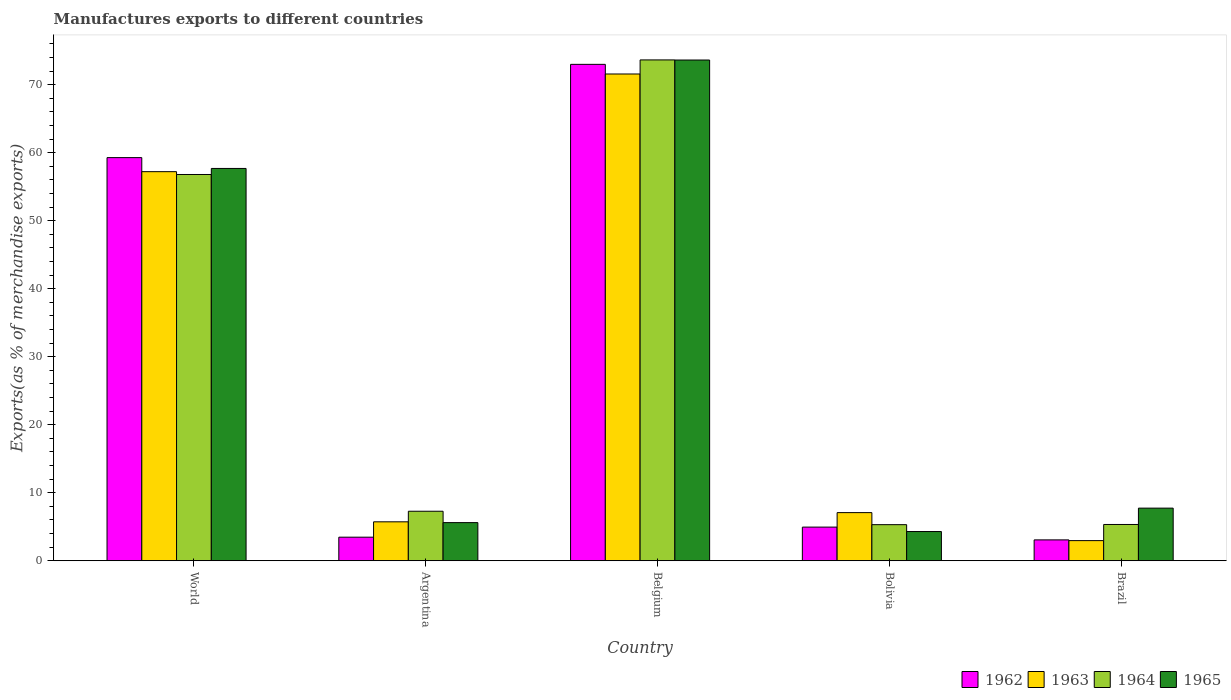How many different coloured bars are there?
Ensure brevity in your answer.  4. How many groups of bars are there?
Your response must be concise. 5. Are the number of bars per tick equal to the number of legend labels?
Your answer should be very brief. Yes. How many bars are there on the 4th tick from the left?
Your response must be concise. 4. What is the label of the 4th group of bars from the left?
Ensure brevity in your answer.  Bolivia. In how many cases, is the number of bars for a given country not equal to the number of legend labels?
Ensure brevity in your answer.  0. What is the percentage of exports to different countries in 1962 in Brazil?
Give a very brief answer. 3.07. Across all countries, what is the maximum percentage of exports to different countries in 1963?
Offer a terse response. 71.56. Across all countries, what is the minimum percentage of exports to different countries in 1964?
Your response must be concise. 5.31. In which country was the percentage of exports to different countries in 1964 minimum?
Keep it short and to the point. Bolivia. What is the total percentage of exports to different countries in 1965 in the graph?
Offer a terse response. 148.94. What is the difference between the percentage of exports to different countries in 1964 in Belgium and that in Brazil?
Make the answer very short. 68.3. What is the difference between the percentage of exports to different countries in 1963 in Bolivia and the percentage of exports to different countries in 1962 in World?
Your response must be concise. -52.19. What is the average percentage of exports to different countries in 1962 per country?
Ensure brevity in your answer.  28.75. What is the difference between the percentage of exports to different countries of/in 1962 and percentage of exports to different countries of/in 1963 in Bolivia?
Provide a short and direct response. -2.13. In how many countries, is the percentage of exports to different countries in 1965 greater than 34 %?
Your answer should be compact. 2. What is the ratio of the percentage of exports to different countries in 1965 in Belgium to that in World?
Keep it short and to the point. 1.28. Is the percentage of exports to different countries in 1962 in Belgium less than that in Brazil?
Your answer should be very brief. No. Is the difference between the percentage of exports to different countries in 1962 in Argentina and World greater than the difference between the percentage of exports to different countries in 1963 in Argentina and World?
Provide a succinct answer. No. What is the difference between the highest and the second highest percentage of exports to different countries in 1963?
Your answer should be compact. 50.12. What is the difference between the highest and the lowest percentage of exports to different countries in 1963?
Keep it short and to the point. 68.6. Is the sum of the percentage of exports to different countries in 1964 in Belgium and Brazil greater than the maximum percentage of exports to different countries in 1963 across all countries?
Your response must be concise. Yes. Is it the case that in every country, the sum of the percentage of exports to different countries in 1964 and percentage of exports to different countries in 1963 is greater than the sum of percentage of exports to different countries in 1962 and percentage of exports to different countries in 1965?
Give a very brief answer. No. What does the 1st bar from the left in Belgium represents?
Your response must be concise. 1962. What does the 3rd bar from the right in Argentina represents?
Your answer should be compact. 1963. Is it the case that in every country, the sum of the percentage of exports to different countries in 1962 and percentage of exports to different countries in 1965 is greater than the percentage of exports to different countries in 1964?
Your answer should be very brief. Yes. Are all the bars in the graph horizontal?
Provide a short and direct response. No. Does the graph contain any zero values?
Your answer should be very brief. No. What is the title of the graph?
Keep it short and to the point. Manufactures exports to different countries. Does "1996" appear as one of the legend labels in the graph?
Offer a terse response. No. What is the label or title of the Y-axis?
Offer a very short reply. Exports(as % of merchandise exports). What is the Exports(as % of merchandise exports) of 1962 in World?
Offer a terse response. 59.27. What is the Exports(as % of merchandise exports) in 1963 in World?
Your answer should be very brief. 57.2. What is the Exports(as % of merchandise exports) in 1964 in World?
Ensure brevity in your answer.  56.79. What is the Exports(as % of merchandise exports) of 1965 in World?
Provide a short and direct response. 57.68. What is the Exports(as % of merchandise exports) in 1962 in Argentina?
Offer a very short reply. 3.47. What is the Exports(as % of merchandise exports) of 1963 in Argentina?
Make the answer very short. 5.73. What is the Exports(as % of merchandise exports) of 1964 in Argentina?
Provide a short and direct response. 7.28. What is the Exports(as % of merchandise exports) of 1965 in Argentina?
Offer a very short reply. 5.61. What is the Exports(as % of merchandise exports) in 1962 in Belgium?
Ensure brevity in your answer.  72.98. What is the Exports(as % of merchandise exports) in 1963 in Belgium?
Provide a short and direct response. 71.56. What is the Exports(as % of merchandise exports) in 1964 in Belgium?
Give a very brief answer. 73.63. What is the Exports(as % of merchandise exports) in 1965 in Belgium?
Give a very brief answer. 73.62. What is the Exports(as % of merchandise exports) of 1962 in Bolivia?
Keep it short and to the point. 4.95. What is the Exports(as % of merchandise exports) of 1963 in Bolivia?
Ensure brevity in your answer.  7.08. What is the Exports(as % of merchandise exports) of 1964 in Bolivia?
Give a very brief answer. 5.31. What is the Exports(as % of merchandise exports) in 1965 in Bolivia?
Your answer should be very brief. 4.3. What is the Exports(as % of merchandise exports) in 1962 in Brazil?
Provide a succinct answer. 3.07. What is the Exports(as % of merchandise exports) in 1963 in Brazil?
Offer a terse response. 2.96. What is the Exports(as % of merchandise exports) in 1964 in Brazil?
Your answer should be compact. 5.34. What is the Exports(as % of merchandise exports) in 1965 in Brazil?
Your answer should be compact. 7.74. Across all countries, what is the maximum Exports(as % of merchandise exports) in 1962?
Keep it short and to the point. 72.98. Across all countries, what is the maximum Exports(as % of merchandise exports) in 1963?
Your response must be concise. 71.56. Across all countries, what is the maximum Exports(as % of merchandise exports) of 1964?
Your response must be concise. 73.63. Across all countries, what is the maximum Exports(as % of merchandise exports) of 1965?
Your response must be concise. 73.62. Across all countries, what is the minimum Exports(as % of merchandise exports) of 1962?
Your response must be concise. 3.07. Across all countries, what is the minimum Exports(as % of merchandise exports) in 1963?
Provide a short and direct response. 2.96. Across all countries, what is the minimum Exports(as % of merchandise exports) in 1964?
Give a very brief answer. 5.31. Across all countries, what is the minimum Exports(as % of merchandise exports) of 1965?
Offer a very short reply. 4.3. What is the total Exports(as % of merchandise exports) in 1962 in the graph?
Offer a terse response. 143.74. What is the total Exports(as % of merchandise exports) of 1963 in the graph?
Provide a succinct answer. 144.54. What is the total Exports(as % of merchandise exports) in 1964 in the graph?
Ensure brevity in your answer.  148.35. What is the total Exports(as % of merchandise exports) in 1965 in the graph?
Ensure brevity in your answer.  148.94. What is the difference between the Exports(as % of merchandise exports) in 1962 in World and that in Argentina?
Ensure brevity in your answer.  55.8. What is the difference between the Exports(as % of merchandise exports) of 1963 in World and that in Argentina?
Keep it short and to the point. 51.48. What is the difference between the Exports(as % of merchandise exports) of 1964 in World and that in Argentina?
Ensure brevity in your answer.  49.51. What is the difference between the Exports(as % of merchandise exports) of 1965 in World and that in Argentina?
Your answer should be compact. 52.07. What is the difference between the Exports(as % of merchandise exports) in 1962 in World and that in Belgium?
Your answer should be very brief. -13.71. What is the difference between the Exports(as % of merchandise exports) of 1963 in World and that in Belgium?
Ensure brevity in your answer.  -14.36. What is the difference between the Exports(as % of merchandise exports) of 1964 in World and that in Belgium?
Make the answer very short. -16.84. What is the difference between the Exports(as % of merchandise exports) in 1965 in World and that in Belgium?
Provide a short and direct response. -15.94. What is the difference between the Exports(as % of merchandise exports) of 1962 in World and that in Bolivia?
Offer a terse response. 54.32. What is the difference between the Exports(as % of merchandise exports) of 1963 in World and that in Bolivia?
Your answer should be compact. 50.12. What is the difference between the Exports(as % of merchandise exports) in 1964 in World and that in Bolivia?
Give a very brief answer. 51.48. What is the difference between the Exports(as % of merchandise exports) in 1965 in World and that in Bolivia?
Offer a terse response. 53.38. What is the difference between the Exports(as % of merchandise exports) in 1962 in World and that in Brazil?
Provide a succinct answer. 56.2. What is the difference between the Exports(as % of merchandise exports) in 1963 in World and that in Brazil?
Give a very brief answer. 54.24. What is the difference between the Exports(as % of merchandise exports) of 1964 in World and that in Brazil?
Your response must be concise. 51.45. What is the difference between the Exports(as % of merchandise exports) of 1965 in World and that in Brazil?
Your response must be concise. 49.94. What is the difference between the Exports(as % of merchandise exports) of 1962 in Argentina and that in Belgium?
Keep it short and to the point. -69.51. What is the difference between the Exports(as % of merchandise exports) in 1963 in Argentina and that in Belgium?
Your answer should be very brief. -65.84. What is the difference between the Exports(as % of merchandise exports) of 1964 in Argentina and that in Belgium?
Your answer should be very brief. -66.35. What is the difference between the Exports(as % of merchandise exports) of 1965 in Argentina and that in Belgium?
Your answer should be very brief. -68.01. What is the difference between the Exports(as % of merchandise exports) in 1962 in Argentina and that in Bolivia?
Keep it short and to the point. -1.48. What is the difference between the Exports(as % of merchandise exports) in 1963 in Argentina and that in Bolivia?
Provide a succinct answer. -1.35. What is the difference between the Exports(as % of merchandise exports) in 1964 in Argentina and that in Bolivia?
Provide a short and direct response. 1.97. What is the difference between the Exports(as % of merchandise exports) in 1965 in Argentina and that in Bolivia?
Make the answer very short. 1.31. What is the difference between the Exports(as % of merchandise exports) in 1962 in Argentina and that in Brazil?
Your response must be concise. 0.4. What is the difference between the Exports(as % of merchandise exports) of 1963 in Argentina and that in Brazil?
Your answer should be very brief. 2.76. What is the difference between the Exports(as % of merchandise exports) in 1964 in Argentina and that in Brazil?
Offer a terse response. 1.95. What is the difference between the Exports(as % of merchandise exports) in 1965 in Argentina and that in Brazil?
Your response must be concise. -2.13. What is the difference between the Exports(as % of merchandise exports) in 1962 in Belgium and that in Bolivia?
Give a very brief answer. 68.03. What is the difference between the Exports(as % of merchandise exports) in 1963 in Belgium and that in Bolivia?
Offer a terse response. 64.48. What is the difference between the Exports(as % of merchandise exports) in 1964 in Belgium and that in Bolivia?
Provide a succinct answer. 68.32. What is the difference between the Exports(as % of merchandise exports) in 1965 in Belgium and that in Bolivia?
Ensure brevity in your answer.  69.32. What is the difference between the Exports(as % of merchandise exports) of 1962 in Belgium and that in Brazil?
Give a very brief answer. 69.91. What is the difference between the Exports(as % of merchandise exports) in 1963 in Belgium and that in Brazil?
Your response must be concise. 68.6. What is the difference between the Exports(as % of merchandise exports) in 1964 in Belgium and that in Brazil?
Your answer should be very brief. 68.3. What is the difference between the Exports(as % of merchandise exports) of 1965 in Belgium and that in Brazil?
Provide a short and direct response. 65.88. What is the difference between the Exports(as % of merchandise exports) in 1962 in Bolivia and that in Brazil?
Your answer should be compact. 1.88. What is the difference between the Exports(as % of merchandise exports) of 1963 in Bolivia and that in Brazil?
Provide a short and direct response. 4.12. What is the difference between the Exports(as % of merchandise exports) in 1964 in Bolivia and that in Brazil?
Give a very brief answer. -0.03. What is the difference between the Exports(as % of merchandise exports) in 1965 in Bolivia and that in Brazil?
Provide a short and direct response. -3.44. What is the difference between the Exports(as % of merchandise exports) of 1962 in World and the Exports(as % of merchandise exports) of 1963 in Argentina?
Provide a short and direct response. 53.55. What is the difference between the Exports(as % of merchandise exports) in 1962 in World and the Exports(as % of merchandise exports) in 1964 in Argentina?
Keep it short and to the point. 51.99. What is the difference between the Exports(as % of merchandise exports) of 1962 in World and the Exports(as % of merchandise exports) of 1965 in Argentina?
Your response must be concise. 53.66. What is the difference between the Exports(as % of merchandise exports) of 1963 in World and the Exports(as % of merchandise exports) of 1964 in Argentina?
Keep it short and to the point. 49.92. What is the difference between the Exports(as % of merchandise exports) in 1963 in World and the Exports(as % of merchandise exports) in 1965 in Argentina?
Your response must be concise. 51.59. What is the difference between the Exports(as % of merchandise exports) in 1964 in World and the Exports(as % of merchandise exports) in 1965 in Argentina?
Give a very brief answer. 51.18. What is the difference between the Exports(as % of merchandise exports) in 1962 in World and the Exports(as % of merchandise exports) in 1963 in Belgium?
Provide a short and direct response. -12.29. What is the difference between the Exports(as % of merchandise exports) of 1962 in World and the Exports(as % of merchandise exports) of 1964 in Belgium?
Offer a terse response. -14.36. What is the difference between the Exports(as % of merchandise exports) of 1962 in World and the Exports(as % of merchandise exports) of 1965 in Belgium?
Offer a terse response. -14.35. What is the difference between the Exports(as % of merchandise exports) of 1963 in World and the Exports(as % of merchandise exports) of 1964 in Belgium?
Offer a very short reply. -16.43. What is the difference between the Exports(as % of merchandise exports) of 1963 in World and the Exports(as % of merchandise exports) of 1965 in Belgium?
Offer a very short reply. -16.41. What is the difference between the Exports(as % of merchandise exports) of 1964 in World and the Exports(as % of merchandise exports) of 1965 in Belgium?
Offer a terse response. -16.83. What is the difference between the Exports(as % of merchandise exports) in 1962 in World and the Exports(as % of merchandise exports) in 1963 in Bolivia?
Ensure brevity in your answer.  52.19. What is the difference between the Exports(as % of merchandise exports) in 1962 in World and the Exports(as % of merchandise exports) in 1964 in Bolivia?
Provide a short and direct response. 53.96. What is the difference between the Exports(as % of merchandise exports) in 1962 in World and the Exports(as % of merchandise exports) in 1965 in Bolivia?
Your answer should be compact. 54.97. What is the difference between the Exports(as % of merchandise exports) in 1963 in World and the Exports(as % of merchandise exports) in 1964 in Bolivia?
Your response must be concise. 51.89. What is the difference between the Exports(as % of merchandise exports) of 1963 in World and the Exports(as % of merchandise exports) of 1965 in Bolivia?
Your answer should be very brief. 52.91. What is the difference between the Exports(as % of merchandise exports) of 1964 in World and the Exports(as % of merchandise exports) of 1965 in Bolivia?
Your response must be concise. 52.49. What is the difference between the Exports(as % of merchandise exports) in 1962 in World and the Exports(as % of merchandise exports) in 1963 in Brazil?
Offer a very short reply. 56.31. What is the difference between the Exports(as % of merchandise exports) of 1962 in World and the Exports(as % of merchandise exports) of 1964 in Brazil?
Offer a very short reply. 53.93. What is the difference between the Exports(as % of merchandise exports) in 1962 in World and the Exports(as % of merchandise exports) in 1965 in Brazil?
Give a very brief answer. 51.53. What is the difference between the Exports(as % of merchandise exports) of 1963 in World and the Exports(as % of merchandise exports) of 1964 in Brazil?
Provide a short and direct response. 51.87. What is the difference between the Exports(as % of merchandise exports) in 1963 in World and the Exports(as % of merchandise exports) in 1965 in Brazil?
Provide a succinct answer. 49.46. What is the difference between the Exports(as % of merchandise exports) in 1964 in World and the Exports(as % of merchandise exports) in 1965 in Brazil?
Your response must be concise. 49.05. What is the difference between the Exports(as % of merchandise exports) of 1962 in Argentina and the Exports(as % of merchandise exports) of 1963 in Belgium?
Ensure brevity in your answer.  -68.1. What is the difference between the Exports(as % of merchandise exports) of 1962 in Argentina and the Exports(as % of merchandise exports) of 1964 in Belgium?
Provide a succinct answer. -70.16. What is the difference between the Exports(as % of merchandise exports) in 1962 in Argentina and the Exports(as % of merchandise exports) in 1965 in Belgium?
Offer a very short reply. -70.15. What is the difference between the Exports(as % of merchandise exports) of 1963 in Argentina and the Exports(as % of merchandise exports) of 1964 in Belgium?
Give a very brief answer. -67.91. What is the difference between the Exports(as % of merchandise exports) in 1963 in Argentina and the Exports(as % of merchandise exports) in 1965 in Belgium?
Offer a terse response. -67.89. What is the difference between the Exports(as % of merchandise exports) of 1964 in Argentina and the Exports(as % of merchandise exports) of 1965 in Belgium?
Provide a succinct answer. -66.33. What is the difference between the Exports(as % of merchandise exports) in 1962 in Argentina and the Exports(as % of merchandise exports) in 1963 in Bolivia?
Provide a short and direct response. -3.61. What is the difference between the Exports(as % of merchandise exports) in 1962 in Argentina and the Exports(as % of merchandise exports) in 1964 in Bolivia?
Your response must be concise. -1.84. What is the difference between the Exports(as % of merchandise exports) of 1962 in Argentina and the Exports(as % of merchandise exports) of 1965 in Bolivia?
Provide a short and direct response. -0.83. What is the difference between the Exports(as % of merchandise exports) in 1963 in Argentina and the Exports(as % of merchandise exports) in 1964 in Bolivia?
Ensure brevity in your answer.  0.42. What is the difference between the Exports(as % of merchandise exports) in 1963 in Argentina and the Exports(as % of merchandise exports) in 1965 in Bolivia?
Your answer should be very brief. 1.43. What is the difference between the Exports(as % of merchandise exports) in 1964 in Argentina and the Exports(as % of merchandise exports) in 1965 in Bolivia?
Provide a short and direct response. 2.98. What is the difference between the Exports(as % of merchandise exports) of 1962 in Argentina and the Exports(as % of merchandise exports) of 1963 in Brazil?
Keep it short and to the point. 0.51. What is the difference between the Exports(as % of merchandise exports) in 1962 in Argentina and the Exports(as % of merchandise exports) in 1964 in Brazil?
Provide a short and direct response. -1.87. What is the difference between the Exports(as % of merchandise exports) in 1962 in Argentina and the Exports(as % of merchandise exports) in 1965 in Brazil?
Offer a very short reply. -4.27. What is the difference between the Exports(as % of merchandise exports) of 1963 in Argentina and the Exports(as % of merchandise exports) of 1964 in Brazil?
Offer a terse response. 0.39. What is the difference between the Exports(as % of merchandise exports) in 1963 in Argentina and the Exports(as % of merchandise exports) in 1965 in Brazil?
Offer a very short reply. -2.01. What is the difference between the Exports(as % of merchandise exports) of 1964 in Argentina and the Exports(as % of merchandise exports) of 1965 in Brazil?
Offer a terse response. -0.46. What is the difference between the Exports(as % of merchandise exports) of 1962 in Belgium and the Exports(as % of merchandise exports) of 1963 in Bolivia?
Provide a succinct answer. 65.9. What is the difference between the Exports(as % of merchandise exports) in 1962 in Belgium and the Exports(as % of merchandise exports) in 1964 in Bolivia?
Ensure brevity in your answer.  67.67. What is the difference between the Exports(as % of merchandise exports) in 1962 in Belgium and the Exports(as % of merchandise exports) in 1965 in Bolivia?
Give a very brief answer. 68.68. What is the difference between the Exports(as % of merchandise exports) of 1963 in Belgium and the Exports(as % of merchandise exports) of 1964 in Bolivia?
Give a very brief answer. 66.25. What is the difference between the Exports(as % of merchandise exports) in 1963 in Belgium and the Exports(as % of merchandise exports) in 1965 in Bolivia?
Give a very brief answer. 67.27. What is the difference between the Exports(as % of merchandise exports) of 1964 in Belgium and the Exports(as % of merchandise exports) of 1965 in Bolivia?
Offer a terse response. 69.34. What is the difference between the Exports(as % of merchandise exports) of 1962 in Belgium and the Exports(as % of merchandise exports) of 1963 in Brazil?
Offer a terse response. 70.02. What is the difference between the Exports(as % of merchandise exports) of 1962 in Belgium and the Exports(as % of merchandise exports) of 1964 in Brazil?
Ensure brevity in your answer.  67.64. What is the difference between the Exports(as % of merchandise exports) of 1962 in Belgium and the Exports(as % of merchandise exports) of 1965 in Brazil?
Your answer should be compact. 65.24. What is the difference between the Exports(as % of merchandise exports) of 1963 in Belgium and the Exports(as % of merchandise exports) of 1964 in Brazil?
Provide a short and direct response. 66.23. What is the difference between the Exports(as % of merchandise exports) of 1963 in Belgium and the Exports(as % of merchandise exports) of 1965 in Brazil?
Your answer should be very brief. 63.82. What is the difference between the Exports(as % of merchandise exports) in 1964 in Belgium and the Exports(as % of merchandise exports) in 1965 in Brazil?
Ensure brevity in your answer.  65.89. What is the difference between the Exports(as % of merchandise exports) of 1962 in Bolivia and the Exports(as % of merchandise exports) of 1963 in Brazil?
Give a very brief answer. 1.99. What is the difference between the Exports(as % of merchandise exports) of 1962 in Bolivia and the Exports(as % of merchandise exports) of 1964 in Brazil?
Keep it short and to the point. -0.39. What is the difference between the Exports(as % of merchandise exports) of 1962 in Bolivia and the Exports(as % of merchandise exports) of 1965 in Brazil?
Ensure brevity in your answer.  -2.79. What is the difference between the Exports(as % of merchandise exports) of 1963 in Bolivia and the Exports(as % of merchandise exports) of 1964 in Brazil?
Make the answer very short. 1.74. What is the difference between the Exports(as % of merchandise exports) of 1963 in Bolivia and the Exports(as % of merchandise exports) of 1965 in Brazil?
Your answer should be very brief. -0.66. What is the difference between the Exports(as % of merchandise exports) in 1964 in Bolivia and the Exports(as % of merchandise exports) in 1965 in Brazil?
Offer a terse response. -2.43. What is the average Exports(as % of merchandise exports) of 1962 per country?
Give a very brief answer. 28.75. What is the average Exports(as % of merchandise exports) of 1963 per country?
Keep it short and to the point. 28.91. What is the average Exports(as % of merchandise exports) in 1964 per country?
Provide a short and direct response. 29.67. What is the average Exports(as % of merchandise exports) in 1965 per country?
Offer a terse response. 29.79. What is the difference between the Exports(as % of merchandise exports) of 1962 and Exports(as % of merchandise exports) of 1963 in World?
Make the answer very short. 2.07. What is the difference between the Exports(as % of merchandise exports) of 1962 and Exports(as % of merchandise exports) of 1964 in World?
Your response must be concise. 2.48. What is the difference between the Exports(as % of merchandise exports) of 1962 and Exports(as % of merchandise exports) of 1965 in World?
Provide a short and direct response. 1.59. What is the difference between the Exports(as % of merchandise exports) in 1963 and Exports(as % of merchandise exports) in 1964 in World?
Offer a terse response. 0.41. What is the difference between the Exports(as % of merchandise exports) in 1963 and Exports(as % of merchandise exports) in 1965 in World?
Provide a succinct answer. -0.47. What is the difference between the Exports(as % of merchandise exports) in 1964 and Exports(as % of merchandise exports) in 1965 in World?
Provide a succinct answer. -0.89. What is the difference between the Exports(as % of merchandise exports) of 1962 and Exports(as % of merchandise exports) of 1963 in Argentina?
Your answer should be very brief. -2.26. What is the difference between the Exports(as % of merchandise exports) of 1962 and Exports(as % of merchandise exports) of 1964 in Argentina?
Give a very brief answer. -3.81. What is the difference between the Exports(as % of merchandise exports) of 1962 and Exports(as % of merchandise exports) of 1965 in Argentina?
Ensure brevity in your answer.  -2.14. What is the difference between the Exports(as % of merchandise exports) in 1963 and Exports(as % of merchandise exports) in 1964 in Argentina?
Your answer should be compact. -1.56. What is the difference between the Exports(as % of merchandise exports) in 1963 and Exports(as % of merchandise exports) in 1965 in Argentina?
Make the answer very short. 0.12. What is the difference between the Exports(as % of merchandise exports) of 1964 and Exports(as % of merchandise exports) of 1965 in Argentina?
Offer a terse response. 1.67. What is the difference between the Exports(as % of merchandise exports) of 1962 and Exports(as % of merchandise exports) of 1963 in Belgium?
Your response must be concise. 1.42. What is the difference between the Exports(as % of merchandise exports) in 1962 and Exports(as % of merchandise exports) in 1964 in Belgium?
Your response must be concise. -0.65. What is the difference between the Exports(as % of merchandise exports) of 1962 and Exports(as % of merchandise exports) of 1965 in Belgium?
Provide a short and direct response. -0.64. What is the difference between the Exports(as % of merchandise exports) in 1963 and Exports(as % of merchandise exports) in 1964 in Belgium?
Offer a terse response. -2.07. What is the difference between the Exports(as % of merchandise exports) of 1963 and Exports(as % of merchandise exports) of 1965 in Belgium?
Your answer should be very brief. -2.05. What is the difference between the Exports(as % of merchandise exports) in 1964 and Exports(as % of merchandise exports) in 1965 in Belgium?
Provide a succinct answer. 0.02. What is the difference between the Exports(as % of merchandise exports) in 1962 and Exports(as % of merchandise exports) in 1963 in Bolivia?
Your answer should be very brief. -2.13. What is the difference between the Exports(as % of merchandise exports) in 1962 and Exports(as % of merchandise exports) in 1964 in Bolivia?
Give a very brief answer. -0.36. What is the difference between the Exports(as % of merchandise exports) in 1962 and Exports(as % of merchandise exports) in 1965 in Bolivia?
Keep it short and to the point. 0.65. What is the difference between the Exports(as % of merchandise exports) in 1963 and Exports(as % of merchandise exports) in 1964 in Bolivia?
Provide a succinct answer. 1.77. What is the difference between the Exports(as % of merchandise exports) of 1963 and Exports(as % of merchandise exports) of 1965 in Bolivia?
Keep it short and to the point. 2.78. What is the difference between the Exports(as % of merchandise exports) of 1964 and Exports(as % of merchandise exports) of 1965 in Bolivia?
Your answer should be compact. 1.01. What is the difference between the Exports(as % of merchandise exports) of 1962 and Exports(as % of merchandise exports) of 1963 in Brazil?
Keep it short and to the point. 0.11. What is the difference between the Exports(as % of merchandise exports) of 1962 and Exports(as % of merchandise exports) of 1964 in Brazil?
Keep it short and to the point. -2.27. What is the difference between the Exports(as % of merchandise exports) of 1962 and Exports(as % of merchandise exports) of 1965 in Brazil?
Offer a terse response. -4.67. What is the difference between the Exports(as % of merchandise exports) in 1963 and Exports(as % of merchandise exports) in 1964 in Brazil?
Make the answer very short. -2.37. What is the difference between the Exports(as % of merchandise exports) in 1963 and Exports(as % of merchandise exports) in 1965 in Brazil?
Provide a short and direct response. -4.78. What is the difference between the Exports(as % of merchandise exports) of 1964 and Exports(as % of merchandise exports) of 1965 in Brazil?
Ensure brevity in your answer.  -2.4. What is the ratio of the Exports(as % of merchandise exports) in 1962 in World to that in Argentina?
Your response must be concise. 17.09. What is the ratio of the Exports(as % of merchandise exports) in 1963 in World to that in Argentina?
Give a very brief answer. 9.99. What is the ratio of the Exports(as % of merchandise exports) of 1964 in World to that in Argentina?
Provide a short and direct response. 7.8. What is the ratio of the Exports(as % of merchandise exports) in 1965 in World to that in Argentina?
Your answer should be compact. 10.28. What is the ratio of the Exports(as % of merchandise exports) in 1962 in World to that in Belgium?
Your response must be concise. 0.81. What is the ratio of the Exports(as % of merchandise exports) of 1963 in World to that in Belgium?
Provide a succinct answer. 0.8. What is the ratio of the Exports(as % of merchandise exports) of 1964 in World to that in Belgium?
Give a very brief answer. 0.77. What is the ratio of the Exports(as % of merchandise exports) of 1965 in World to that in Belgium?
Your answer should be compact. 0.78. What is the ratio of the Exports(as % of merchandise exports) of 1962 in World to that in Bolivia?
Your response must be concise. 11.97. What is the ratio of the Exports(as % of merchandise exports) in 1963 in World to that in Bolivia?
Ensure brevity in your answer.  8.08. What is the ratio of the Exports(as % of merchandise exports) of 1964 in World to that in Bolivia?
Provide a succinct answer. 10.7. What is the ratio of the Exports(as % of merchandise exports) in 1965 in World to that in Bolivia?
Your response must be concise. 13.42. What is the ratio of the Exports(as % of merchandise exports) in 1962 in World to that in Brazil?
Provide a succinct answer. 19.3. What is the ratio of the Exports(as % of merchandise exports) of 1963 in World to that in Brazil?
Your answer should be compact. 19.31. What is the ratio of the Exports(as % of merchandise exports) in 1964 in World to that in Brazil?
Keep it short and to the point. 10.64. What is the ratio of the Exports(as % of merchandise exports) in 1965 in World to that in Brazil?
Provide a short and direct response. 7.45. What is the ratio of the Exports(as % of merchandise exports) of 1962 in Argentina to that in Belgium?
Provide a succinct answer. 0.05. What is the ratio of the Exports(as % of merchandise exports) of 1964 in Argentina to that in Belgium?
Offer a very short reply. 0.1. What is the ratio of the Exports(as % of merchandise exports) of 1965 in Argentina to that in Belgium?
Your answer should be compact. 0.08. What is the ratio of the Exports(as % of merchandise exports) in 1962 in Argentina to that in Bolivia?
Provide a succinct answer. 0.7. What is the ratio of the Exports(as % of merchandise exports) in 1963 in Argentina to that in Bolivia?
Ensure brevity in your answer.  0.81. What is the ratio of the Exports(as % of merchandise exports) of 1964 in Argentina to that in Bolivia?
Provide a succinct answer. 1.37. What is the ratio of the Exports(as % of merchandise exports) of 1965 in Argentina to that in Bolivia?
Provide a short and direct response. 1.31. What is the ratio of the Exports(as % of merchandise exports) in 1962 in Argentina to that in Brazil?
Your answer should be very brief. 1.13. What is the ratio of the Exports(as % of merchandise exports) in 1963 in Argentina to that in Brazil?
Offer a very short reply. 1.93. What is the ratio of the Exports(as % of merchandise exports) of 1964 in Argentina to that in Brazil?
Provide a succinct answer. 1.36. What is the ratio of the Exports(as % of merchandise exports) of 1965 in Argentina to that in Brazil?
Provide a succinct answer. 0.72. What is the ratio of the Exports(as % of merchandise exports) of 1962 in Belgium to that in Bolivia?
Your response must be concise. 14.74. What is the ratio of the Exports(as % of merchandise exports) in 1963 in Belgium to that in Bolivia?
Your answer should be very brief. 10.11. What is the ratio of the Exports(as % of merchandise exports) in 1964 in Belgium to that in Bolivia?
Provide a short and direct response. 13.87. What is the ratio of the Exports(as % of merchandise exports) in 1965 in Belgium to that in Bolivia?
Your answer should be compact. 17.13. What is the ratio of the Exports(as % of merchandise exports) of 1962 in Belgium to that in Brazil?
Make the answer very short. 23.77. What is the ratio of the Exports(as % of merchandise exports) in 1963 in Belgium to that in Brazil?
Give a very brief answer. 24.16. What is the ratio of the Exports(as % of merchandise exports) in 1964 in Belgium to that in Brazil?
Give a very brief answer. 13.8. What is the ratio of the Exports(as % of merchandise exports) in 1965 in Belgium to that in Brazil?
Ensure brevity in your answer.  9.51. What is the ratio of the Exports(as % of merchandise exports) of 1962 in Bolivia to that in Brazil?
Make the answer very short. 1.61. What is the ratio of the Exports(as % of merchandise exports) of 1963 in Bolivia to that in Brazil?
Provide a succinct answer. 2.39. What is the ratio of the Exports(as % of merchandise exports) of 1964 in Bolivia to that in Brazil?
Offer a terse response. 0.99. What is the ratio of the Exports(as % of merchandise exports) in 1965 in Bolivia to that in Brazil?
Provide a succinct answer. 0.56. What is the difference between the highest and the second highest Exports(as % of merchandise exports) of 1962?
Make the answer very short. 13.71. What is the difference between the highest and the second highest Exports(as % of merchandise exports) in 1963?
Offer a terse response. 14.36. What is the difference between the highest and the second highest Exports(as % of merchandise exports) of 1964?
Your response must be concise. 16.84. What is the difference between the highest and the second highest Exports(as % of merchandise exports) of 1965?
Give a very brief answer. 15.94. What is the difference between the highest and the lowest Exports(as % of merchandise exports) in 1962?
Offer a terse response. 69.91. What is the difference between the highest and the lowest Exports(as % of merchandise exports) in 1963?
Provide a succinct answer. 68.6. What is the difference between the highest and the lowest Exports(as % of merchandise exports) in 1964?
Offer a terse response. 68.32. What is the difference between the highest and the lowest Exports(as % of merchandise exports) of 1965?
Make the answer very short. 69.32. 